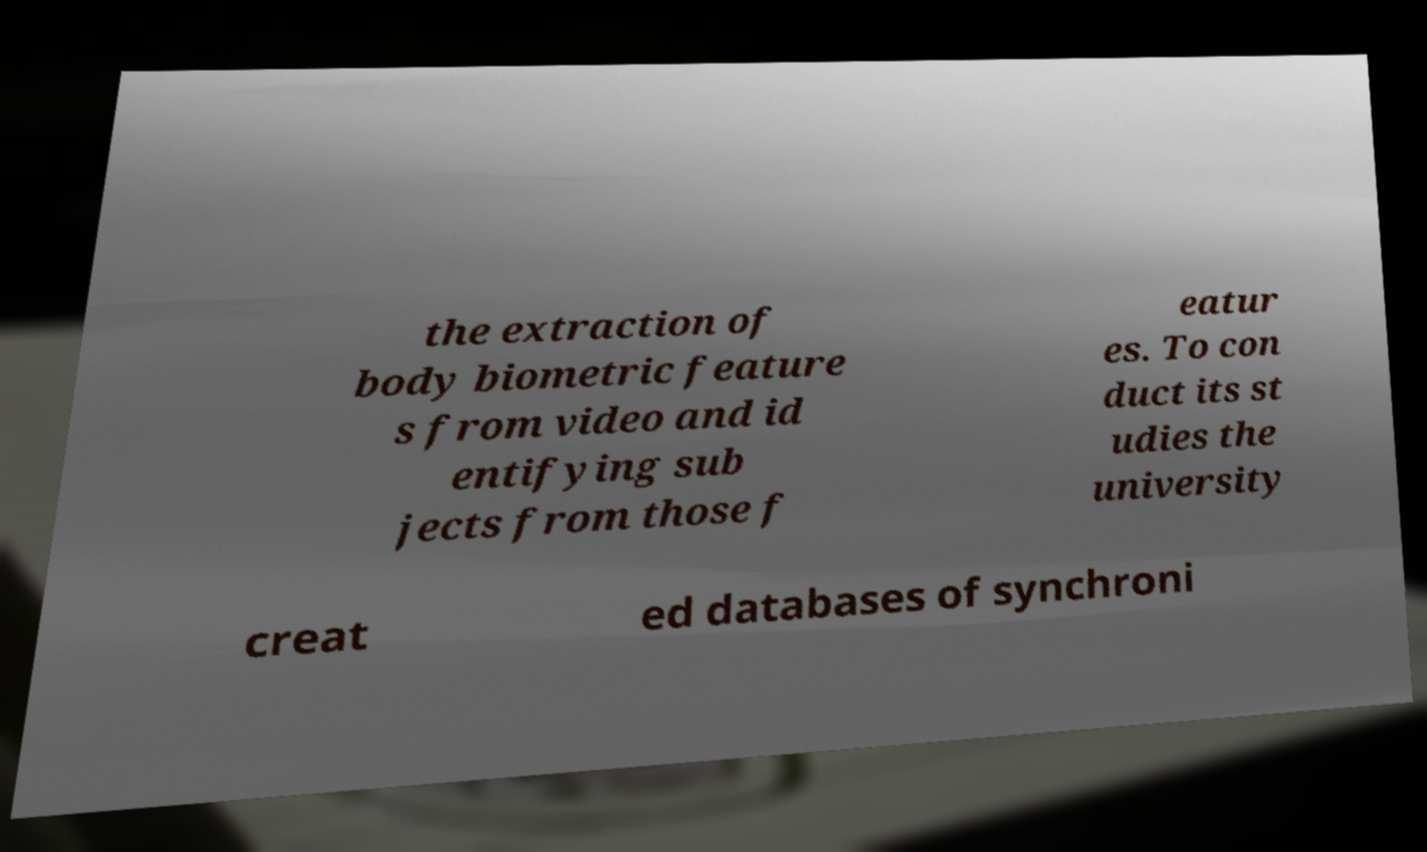There's text embedded in this image that I need extracted. Can you transcribe it verbatim? the extraction of body biometric feature s from video and id entifying sub jects from those f eatur es. To con duct its st udies the university creat ed databases of synchroni 